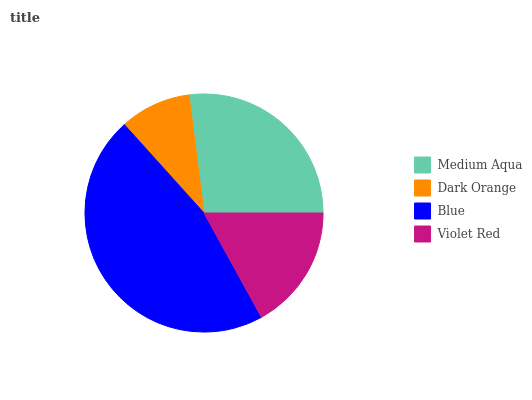Is Dark Orange the minimum?
Answer yes or no. Yes. Is Blue the maximum?
Answer yes or no. Yes. Is Blue the minimum?
Answer yes or no. No. Is Dark Orange the maximum?
Answer yes or no. No. Is Blue greater than Dark Orange?
Answer yes or no. Yes. Is Dark Orange less than Blue?
Answer yes or no. Yes. Is Dark Orange greater than Blue?
Answer yes or no. No. Is Blue less than Dark Orange?
Answer yes or no. No. Is Medium Aqua the high median?
Answer yes or no. Yes. Is Violet Red the low median?
Answer yes or no. Yes. Is Blue the high median?
Answer yes or no. No. Is Blue the low median?
Answer yes or no. No. 